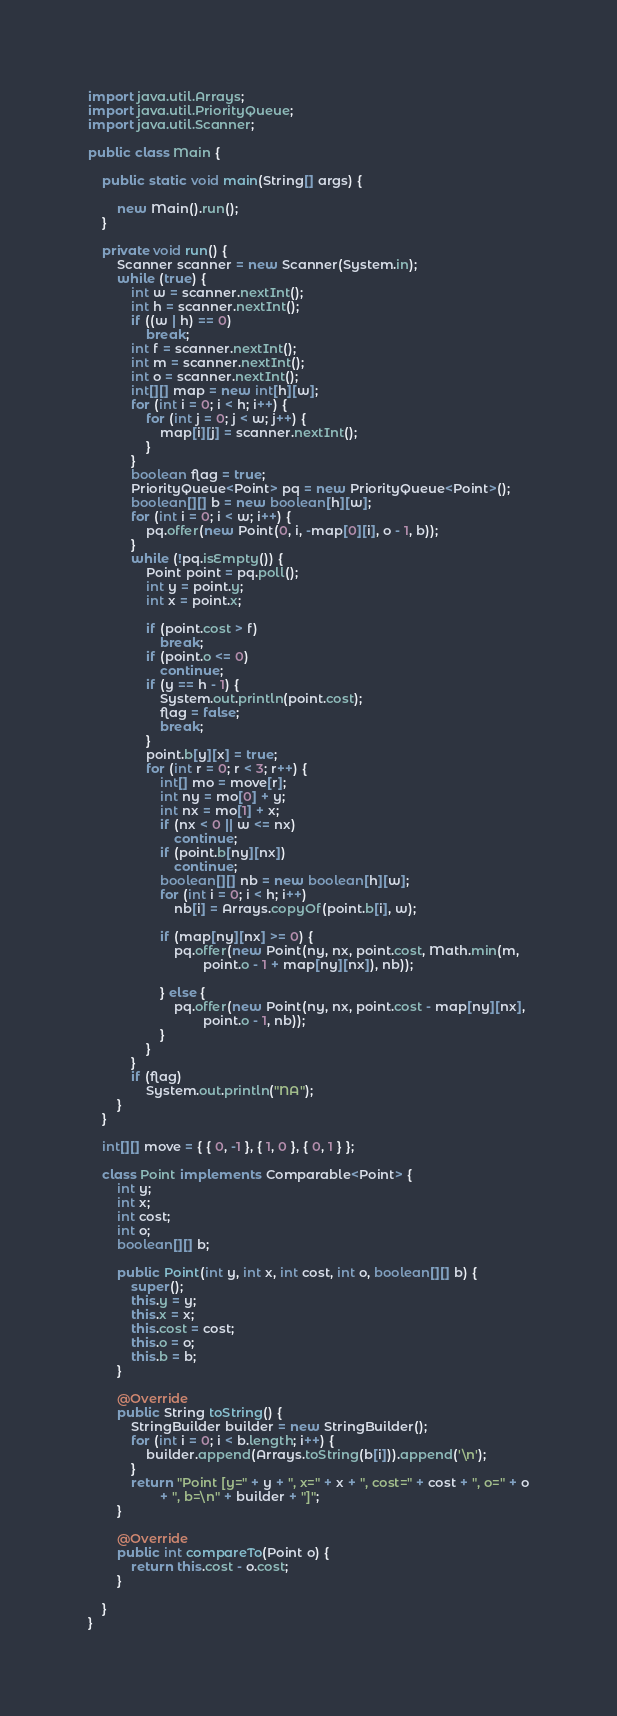Convert code to text. <code><loc_0><loc_0><loc_500><loc_500><_Java_>
import java.util.Arrays;
import java.util.PriorityQueue;
import java.util.Scanner;

public class Main {

	public static void main(String[] args) {

		new Main().run();
	}

	private void run() {
		Scanner scanner = new Scanner(System.in);
		while (true) {
			int w = scanner.nextInt();
			int h = scanner.nextInt();
			if ((w | h) == 0)
				break;
			int f = scanner.nextInt();
			int m = scanner.nextInt();
			int o = scanner.nextInt();
			int[][] map = new int[h][w];
			for (int i = 0; i < h; i++) {
				for (int j = 0; j < w; j++) {
					map[i][j] = scanner.nextInt();
				}
			}
			boolean flag = true;
			PriorityQueue<Point> pq = new PriorityQueue<Point>();
			boolean[][] b = new boolean[h][w];
			for (int i = 0; i < w; i++) {
				pq.offer(new Point(0, i, -map[0][i], o - 1, b));
			}
			while (!pq.isEmpty()) {
				Point point = pq.poll();
				int y = point.y;
				int x = point.x;
				
				if (point.cost > f)
					break;
				if (point.o <= 0)
					continue;
				if (y == h - 1) {
					System.out.println(point.cost);
					flag = false;
					break;
				}
				point.b[y][x] = true;
				for (int r = 0; r < 3; r++) {
					int[] mo = move[r];
					int ny = mo[0] + y;
					int nx = mo[1] + x;
					if (nx < 0 || w <= nx)
						continue;
					if (point.b[ny][nx])
						continue;
					boolean[][] nb = new boolean[h][w];
					for (int i = 0; i < h; i++)
						nb[i] = Arrays.copyOf(point.b[i], w);

					if (map[ny][nx] >= 0) {
						pq.offer(new Point(ny, nx, point.cost, Math.min(m,
								point.o - 1 + map[ny][nx]), nb));

					} else {
						pq.offer(new Point(ny, nx, point.cost - map[ny][nx],
								point.o - 1, nb));
					}
				}
			}
			if (flag)
				System.out.println("NA");
		}
	}

	int[][] move = { { 0, -1 }, { 1, 0 }, { 0, 1 } };

	class Point implements Comparable<Point> {
		int y;
		int x;
		int cost;
		int o;
		boolean[][] b;

		public Point(int y, int x, int cost, int o, boolean[][] b) {
			super();
			this.y = y;
			this.x = x;
			this.cost = cost;
			this.o = o;
			this.b = b;
		}

		@Override
		public String toString() {
			StringBuilder builder = new StringBuilder();
			for (int i = 0; i < b.length; i++) {
				builder.append(Arrays.toString(b[i])).append('\n');
			}
			return "Point [y=" + y + ", x=" + x + ", cost=" + cost + ", o=" + o
					+ ", b=\n" + builder + "]";
		}

		@Override
		public int compareTo(Point o) {
			return this.cost - o.cost;
		}

	}
}</code> 